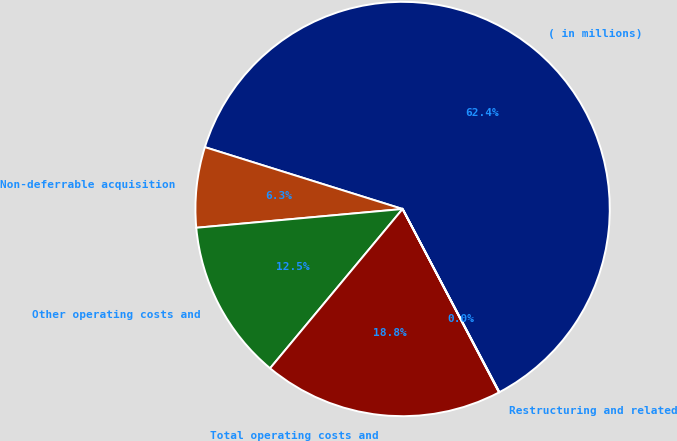Convert chart. <chart><loc_0><loc_0><loc_500><loc_500><pie_chart><fcel>( in millions)<fcel>Non-deferrable acquisition<fcel>Other operating costs and<fcel>Total operating costs and<fcel>Restructuring and related<nl><fcel>62.43%<fcel>6.27%<fcel>12.51%<fcel>18.75%<fcel>0.03%<nl></chart> 